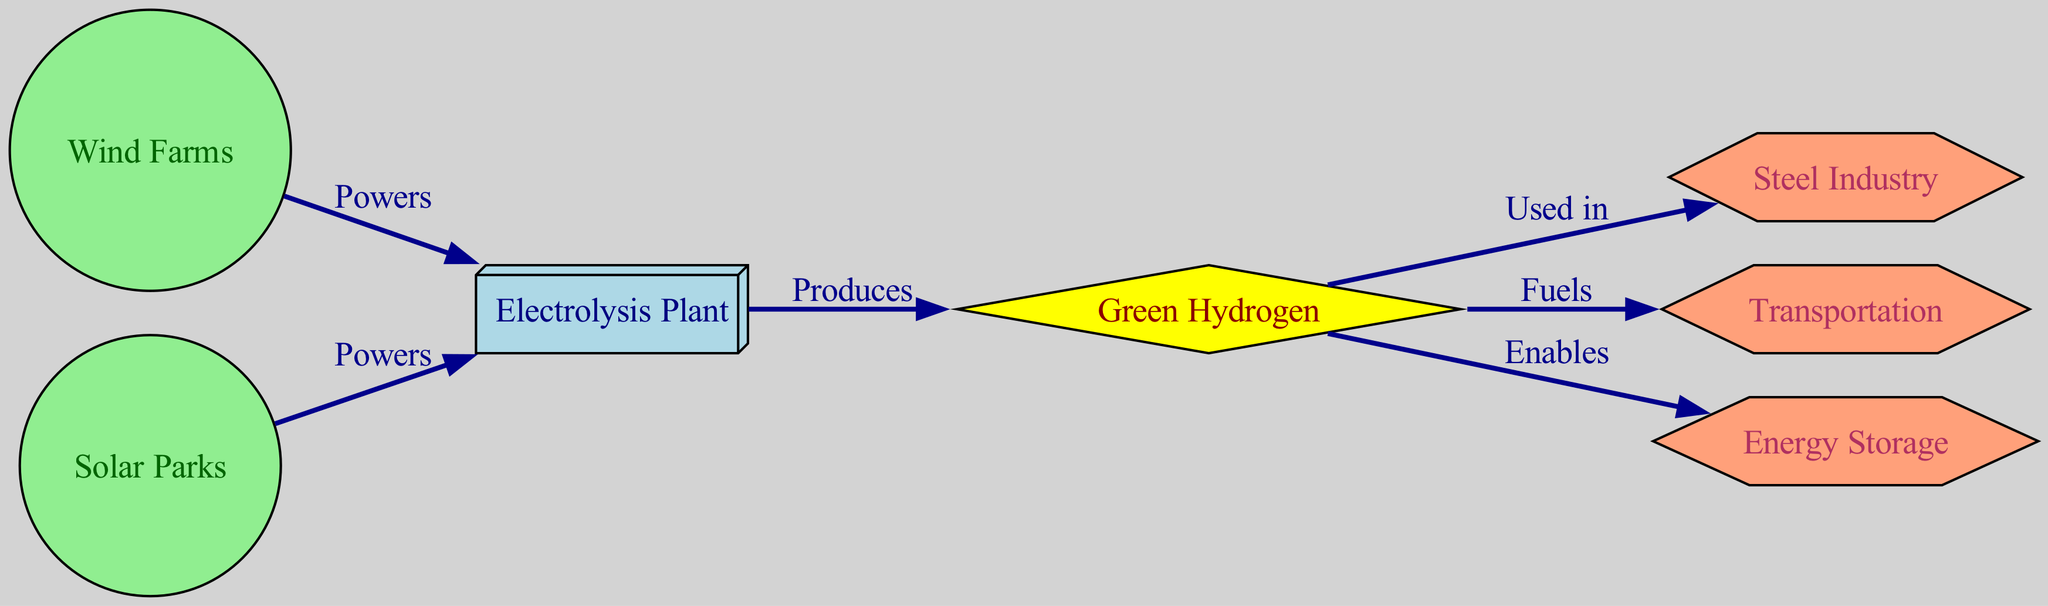What are the two renewable energy sources that power the electrolysis plant? The diagram indicates that both Wind Farms and Solar Parks are the sources that power the Electrolysis Plant, as shown by the edges connecting these nodes with the label "Powers."
Answer: Wind Farms and Solar Parks How many applications are there for green hydrogen? The diagram lists three distinct applications for Green Hydrogen: Steel Industry, Transportation, and Energy Storage, as represented by the connections from the Green Hydrogen node.
Answer: Three What kind of product is green hydrogen classified as in the diagram? Green Hydrogen is represented as a diamond-shaped node in the diagram, which typically denotes a product. It specifically indicates its classification as a product in the diagram.
Answer: Product Which facility produces green hydrogen? The Electrolysis Plant is the facility responsible for producing Green Hydrogen, as indicated by the directed edge from the Electrolysis Plant to the Green Hydrogen node labeled "Produces."
Answer: Electrolysis Plant What application does green hydrogen enable according to the diagram? The diagram shows that Green Hydrogen enables Energy Storage, as denoted by the directed edge leading to the Energy Storage node with the label "Enables."
Answer: Energy Storage Which industry uses green hydrogen as indicated in the diagram? The Steel Industry is marked in the diagram as an application that uses Green Hydrogen, shown by the directed edge connecting these two nodes with the label "Used in."
Answer: Steel Industry How many renewable energy sources are shown in the diagram? The diagram displays two renewable energy sources: Wind Farms and Solar Parks, which are both listed in the nodes section.
Answer: Two What is the relationship between solar parks and the electrolysis plant? The relationship is that Solar Parks power the Electrolysis Plant, as illustrated by the directed edge from Solar Parks to the Electrolysis Plant labeled "Powers."
Answer: Powers What defines the shape of the production facility in this diagram? The Electrolysis Plant, which is categorized as a Production Facility, is illustrated as a box-shaped node, indicating its classification based on the shape provided for that type in the diagram.
Answer: Box-shaped node 